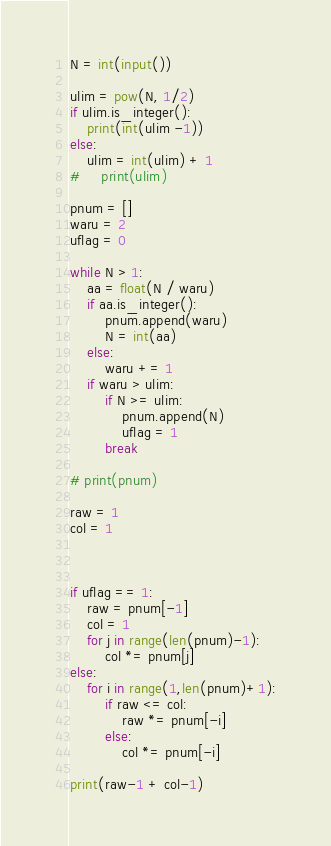<code> <loc_0><loc_0><loc_500><loc_500><_Python_>N = int(input())

ulim = pow(N, 1/2)
if ulim.is_integer():
    print(int(ulim -1))
else:
    ulim = int(ulim) + 1
#     print(ulim)

pnum = []
waru = 2
uflag = 0

while N > 1:
    aa = float(N / waru)
    if aa.is_integer():
        pnum.append(waru)
        N = int(aa)
    else:
        waru += 1
    if waru > ulim:
        if N >= ulim:
            pnum.append(N)
            uflag = 1
        break

# print(pnum)

raw = 1
col = 1



if uflag == 1:
    raw = pnum[-1]
    col = 1
    for j in range(len(pnum)-1):
        col *= pnum[j]
else:
    for i in range(1,len(pnum)+1):
        if raw <= col:
            raw *= pnum[-i]
        else:
            col *= pnum[-i]
        
print(raw-1 + col-1)</code> 